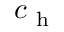Convert formula to latex. <formula><loc_0><loc_0><loc_500><loc_500>c _ { h }</formula> 